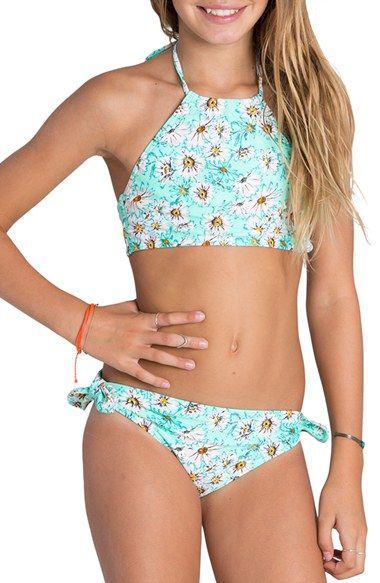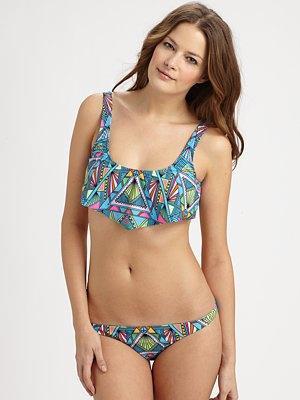The first image is the image on the left, the second image is the image on the right. For the images displayed, is the sentence "One bikini is tied with bows." factually correct? Answer yes or no. Yes. The first image is the image on the left, the second image is the image on the right. Given the left and right images, does the statement "the model in the image on the left has her hand on her hip" hold true? Answer yes or no. Yes. 